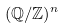<formula> <loc_0><loc_0><loc_500><loc_500>( \mathbb { Q } / \mathbb { Z } ) ^ { n }</formula> 